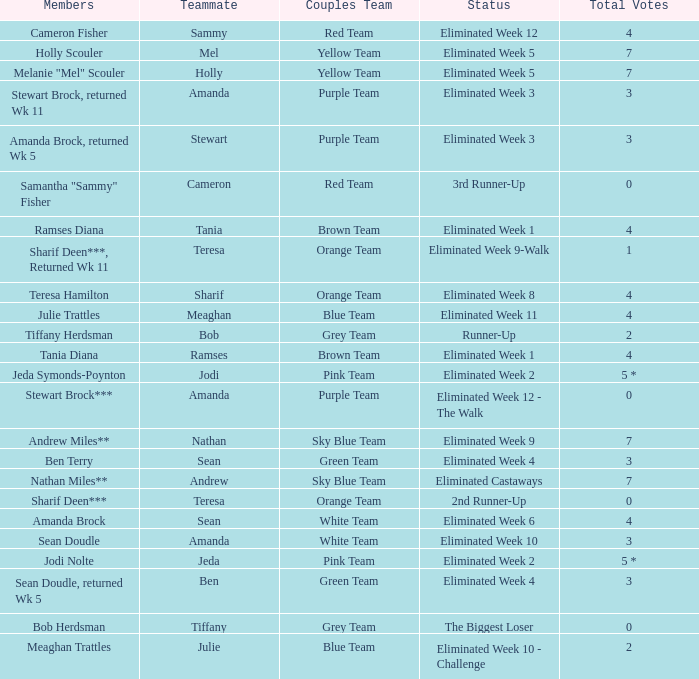What was Holly Scouler's total votes 7.0. 